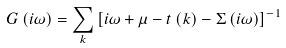Convert formula to latex. <formula><loc_0><loc_0><loc_500><loc_500>G \left ( i \omega \right ) = \sum _ { k } \left [ i \omega + \mu - t \left ( k \right ) - \Sigma \left ( i \omega \right ) \right ] ^ { - 1 }</formula> 